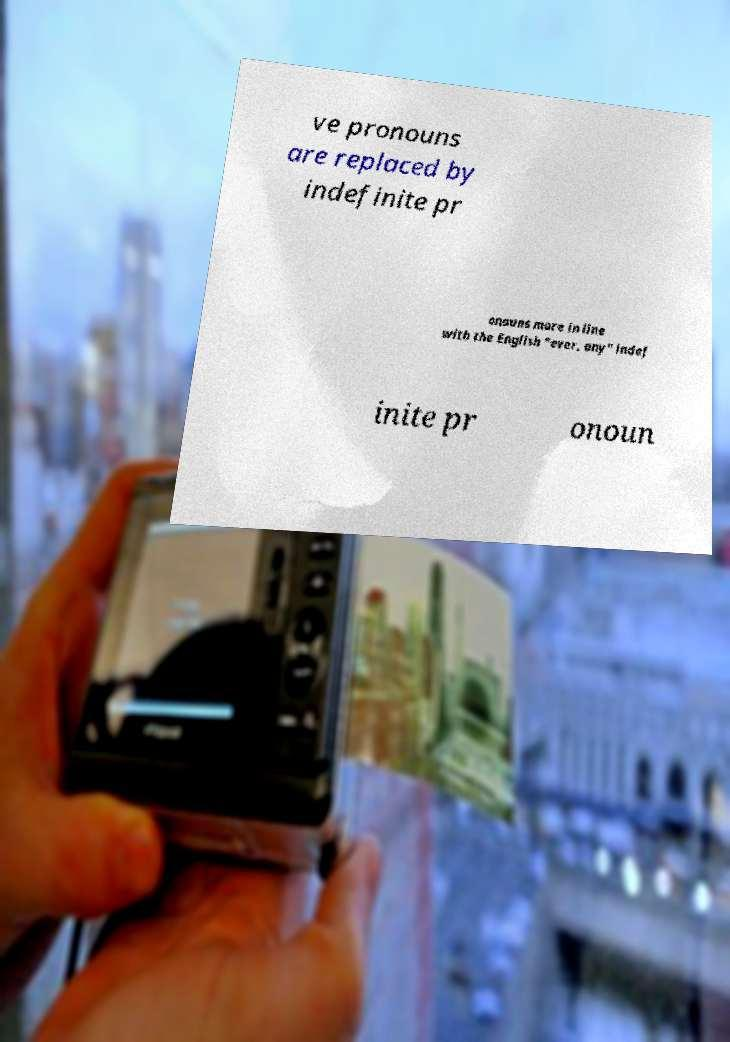Could you extract and type out the text from this image? ve pronouns are replaced by indefinite pr onouns more in line with the English "ever, any" indef inite pr onoun 